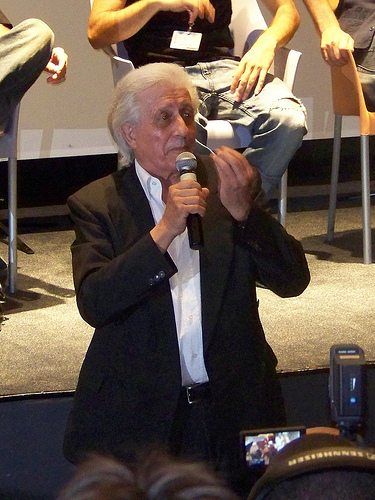<image>
Is there a man on the chair? Yes. Looking at the image, I can see the man is positioned on top of the chair, with the chair providing support. Where is the man in relation to the camera? Is it behind the camera? No. The man is not behind the camera. From this viewpoint, the man appears to be positioned elsewhere in the scene. 